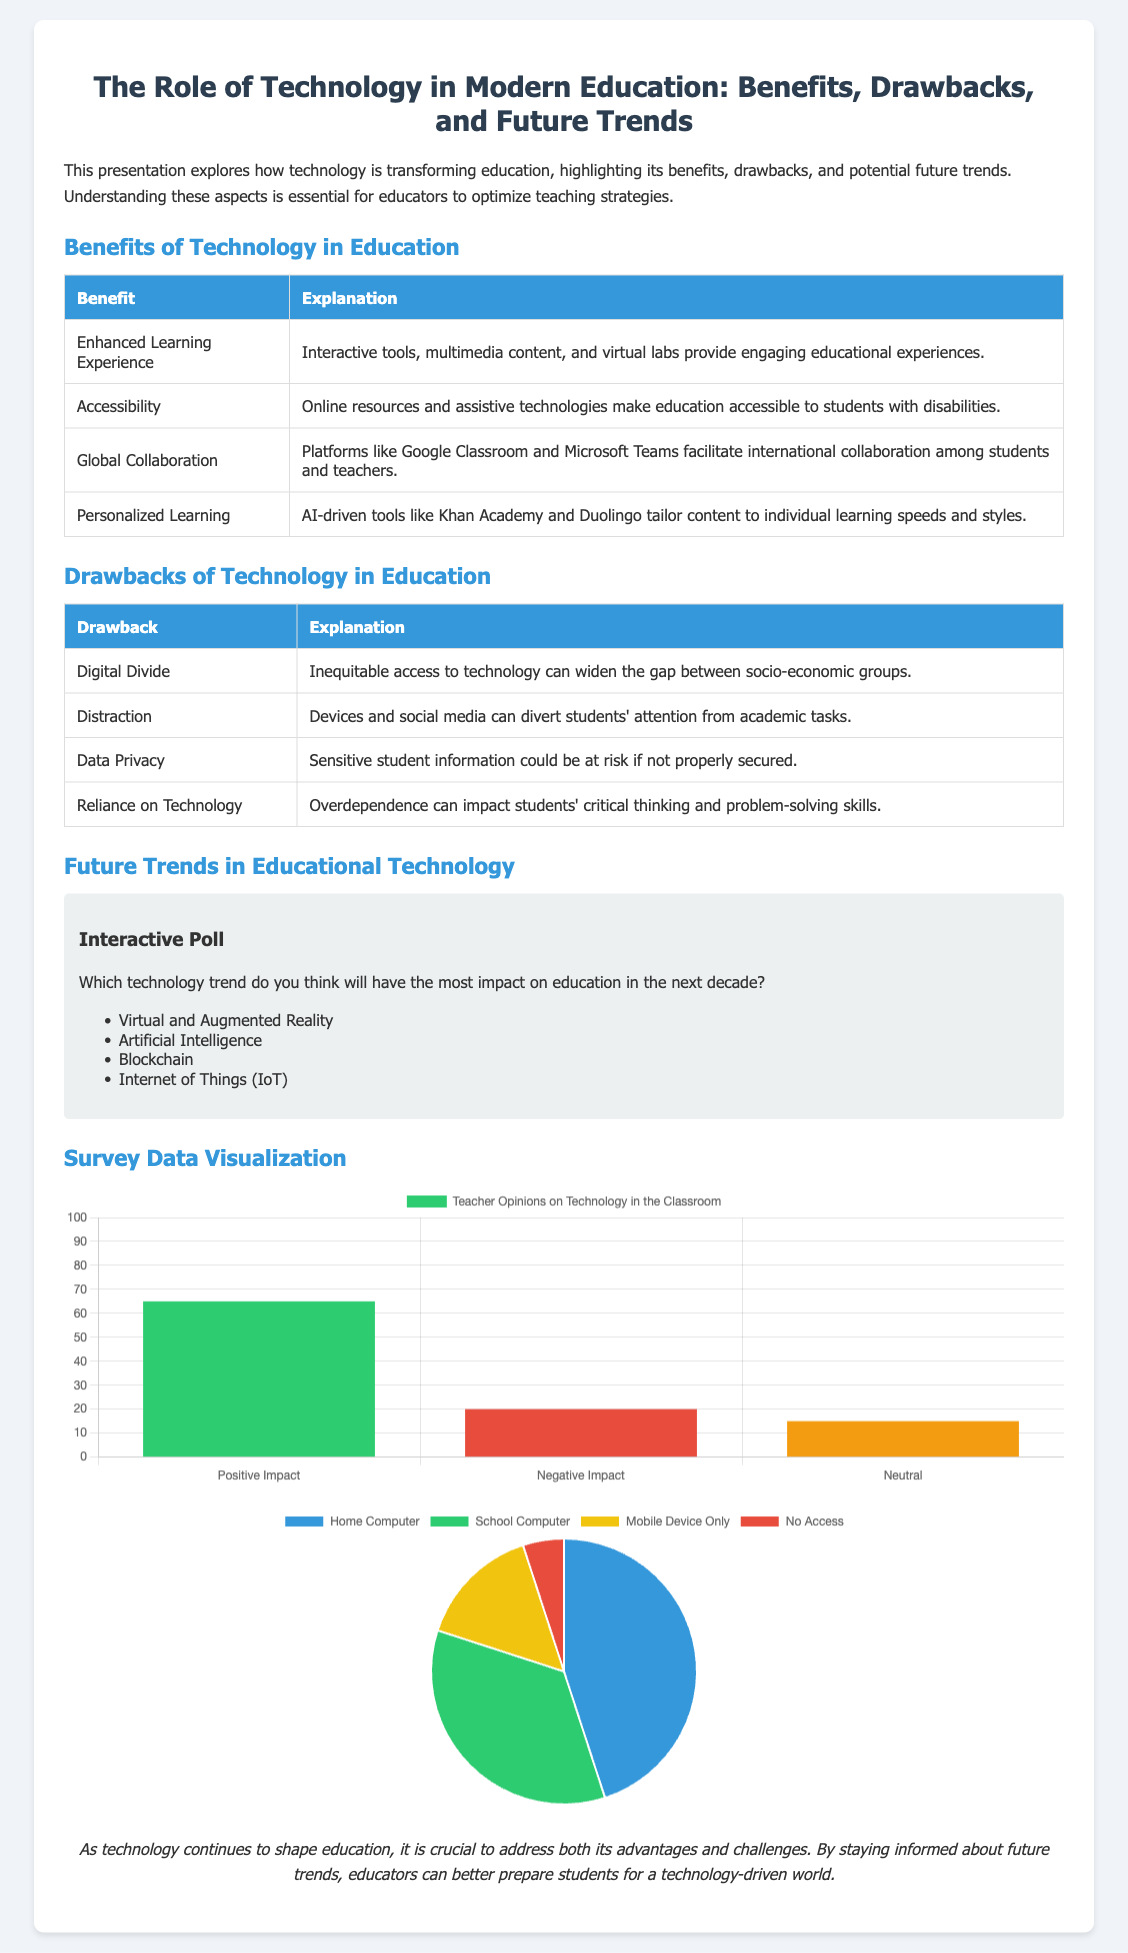What are two benefits of technology in education? The document lists benefits such as Enhanced Learning Experience and Accessibility.
Answer: Enhanced Learning Experience, Accessibility What are two drawbacks of technology in education? The document provides drawbacks including Digital Divide and Distraction.
Answer: Digital Divide, Distraction What percentage of teachers believe technology has a positive impact? The survey chart indicates that 65% of teachers view technology positively.
Answer: 65 What technology trend is least likely to impact education in the next decade, according to the interactive poll? The interactive poll does not specify which trend is least likely but includes Virtual and Augmented Reality, Artificial Intelligence, Blockchain, and IoT.
Answer: Not applicable (no answer provided) What is the total percentage of teachers who have a negative or neutral opinion on technology in the classroom? The data shows 20% negative and 15% neutral, totaling 35%.
Answer: 35 How many students have access to a home computer for schoolwork? The pie chart indicates that 45% of students have access to a home computer.
Answer: 45 What is one potential future trend in educational technology highlighted in the presentation? The document mentions trends like Virtual and Augmented Reality, Artificial Intelligence, Blockchain, and IoT.
Answer: Virtual and Augmented Reality What color represents students who have no access to technology, according to the student access chart? The pie chart uses red to represent students with no access.
Answer: Red 